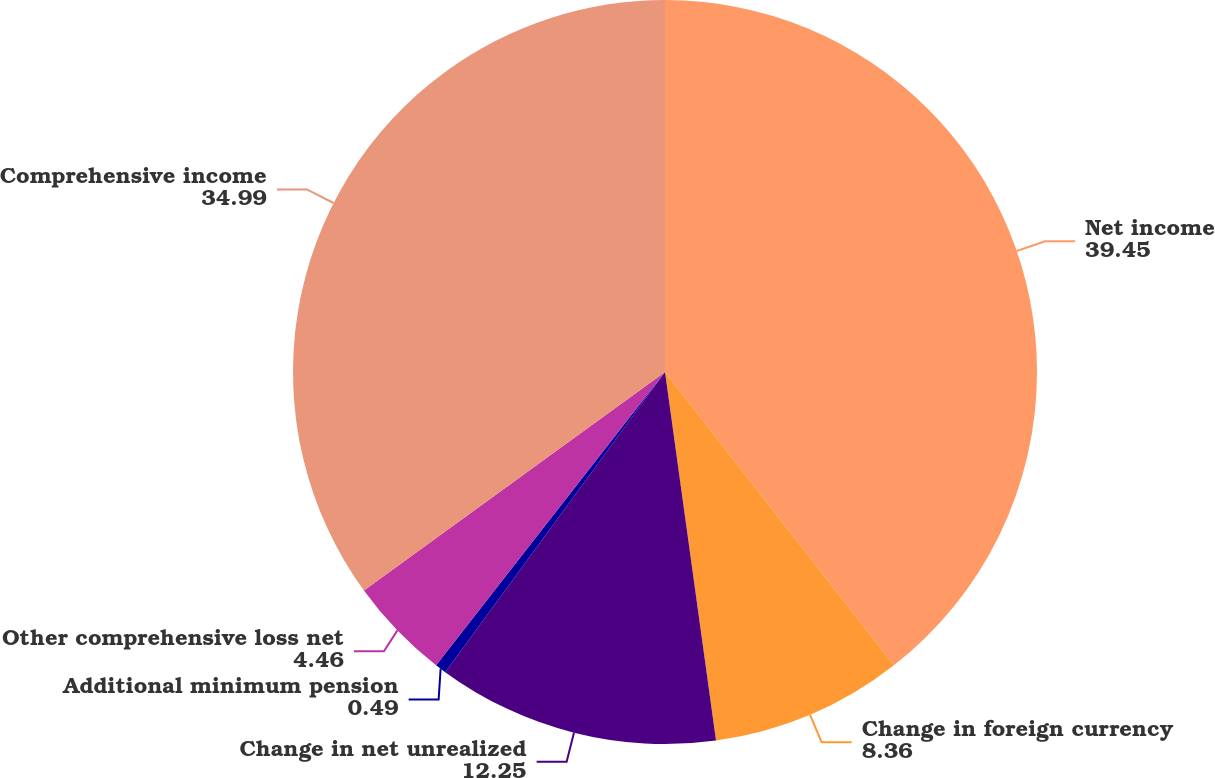Convert chart to OTSL. <chart><loc_0><loc_0><loc_500><loc_500><pie_chart><fcel>Net income<fcel>Change in foreign currency<fcel>Change in net unrealized<fcel>Additional minimum pension<fcel>Other comprehensive loss net<fcel>Comprehensive income<nl><fcel>39.45%<fcel>8.36%<fcel>12.25%<fcel>0.49%<fcel>4.46%<fcel>34.99%<nl></chart> 